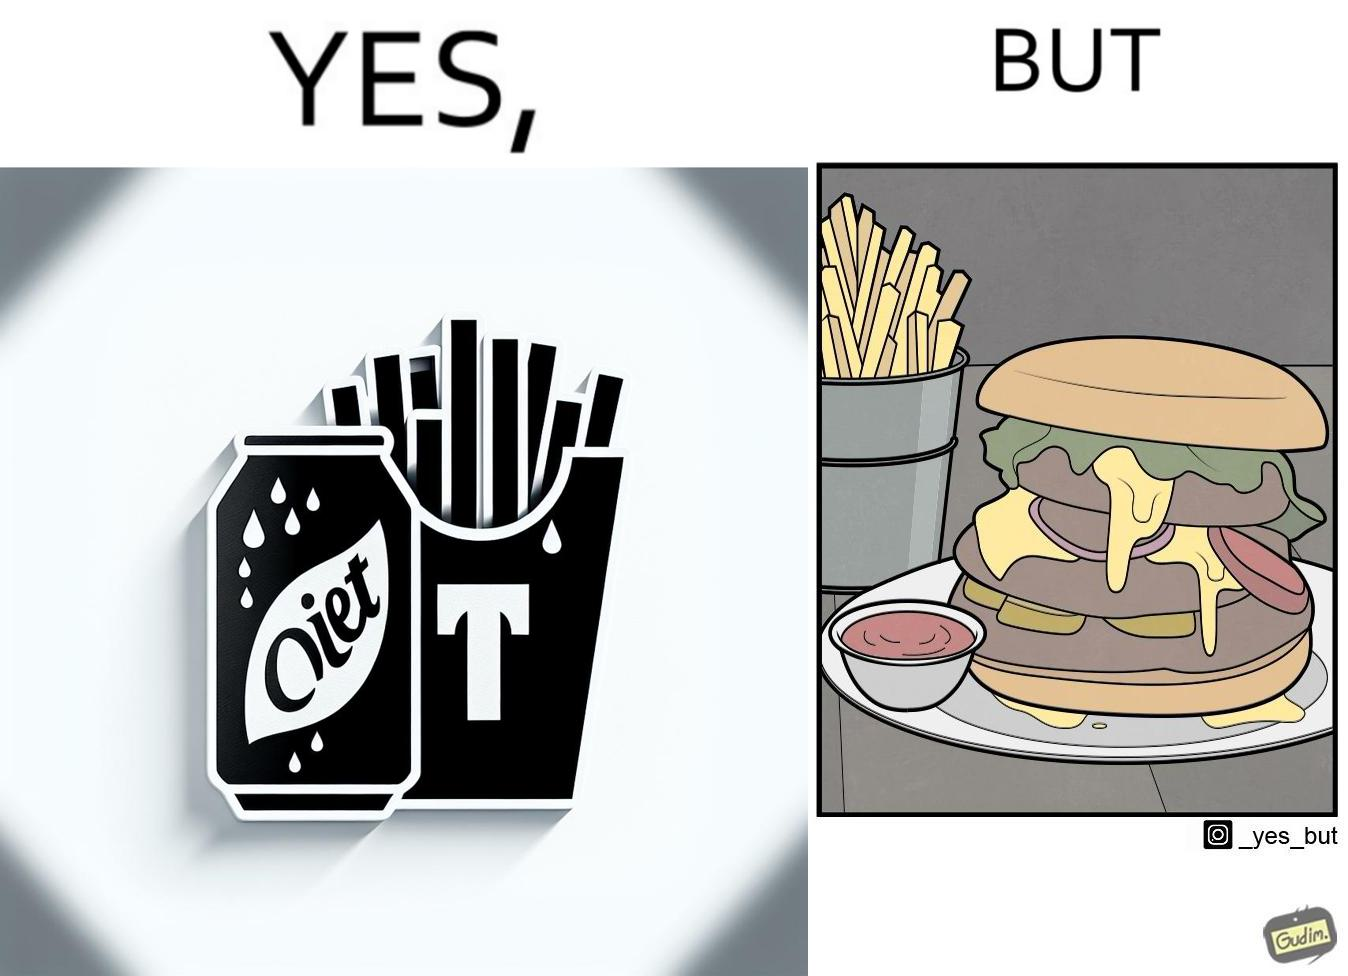Would you classify this image as satirical? Yes, this image is satirical. 